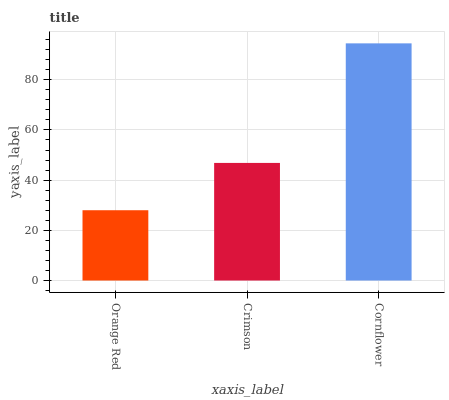Is Orange Red the minimum?
Answer yes or no. Yes. Is Cornflower the maximum?
Answer yes or no. Yes. Is Crimson the minimum?
Answer yes or no. No. Is Crimson the maximum?
Answer yes or no. No. Is Crimson greater than Orange Red?
Answer yes or no. Yes. Is Orange Red less than Crimson?
Answer yes or no. Yes. Is Orange Red greater than Crimson?
Answer yes or no. No. Is Crimson less than Orange Red?
Answer yes or no. No. Is Crimson the high median?
Answer yes or no. Yes. Is Crimson the low median?
Answer yes or no. Yes. Is Cornflower the high median?
Answer yes or no. No. Is Orange Red the low median?
Answer yes or no. No. 